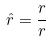<formula> <loc_0><loc_0><loc_500><loc_500>\hat { r } = \frac { r } { r }</formula> 